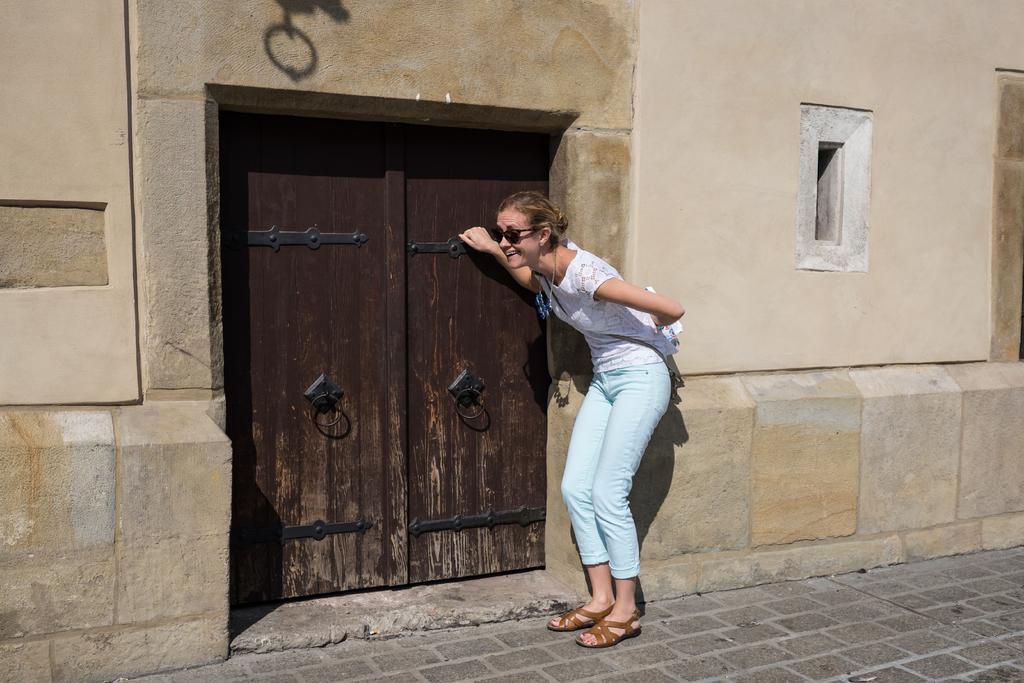Describe this image in one or two sentences. In this image, we can see a person holding an object is knocking the door. We can see the wall with some objects. We can see the ground. 